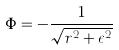Convert formula to latex. <formula><loc_0><loc_0><loc_500><loc_500>\Phi = - \frac { 1 } { \sqrt { r ^ { 2 } + \epsilon ^ { 2 } } }</formula> 